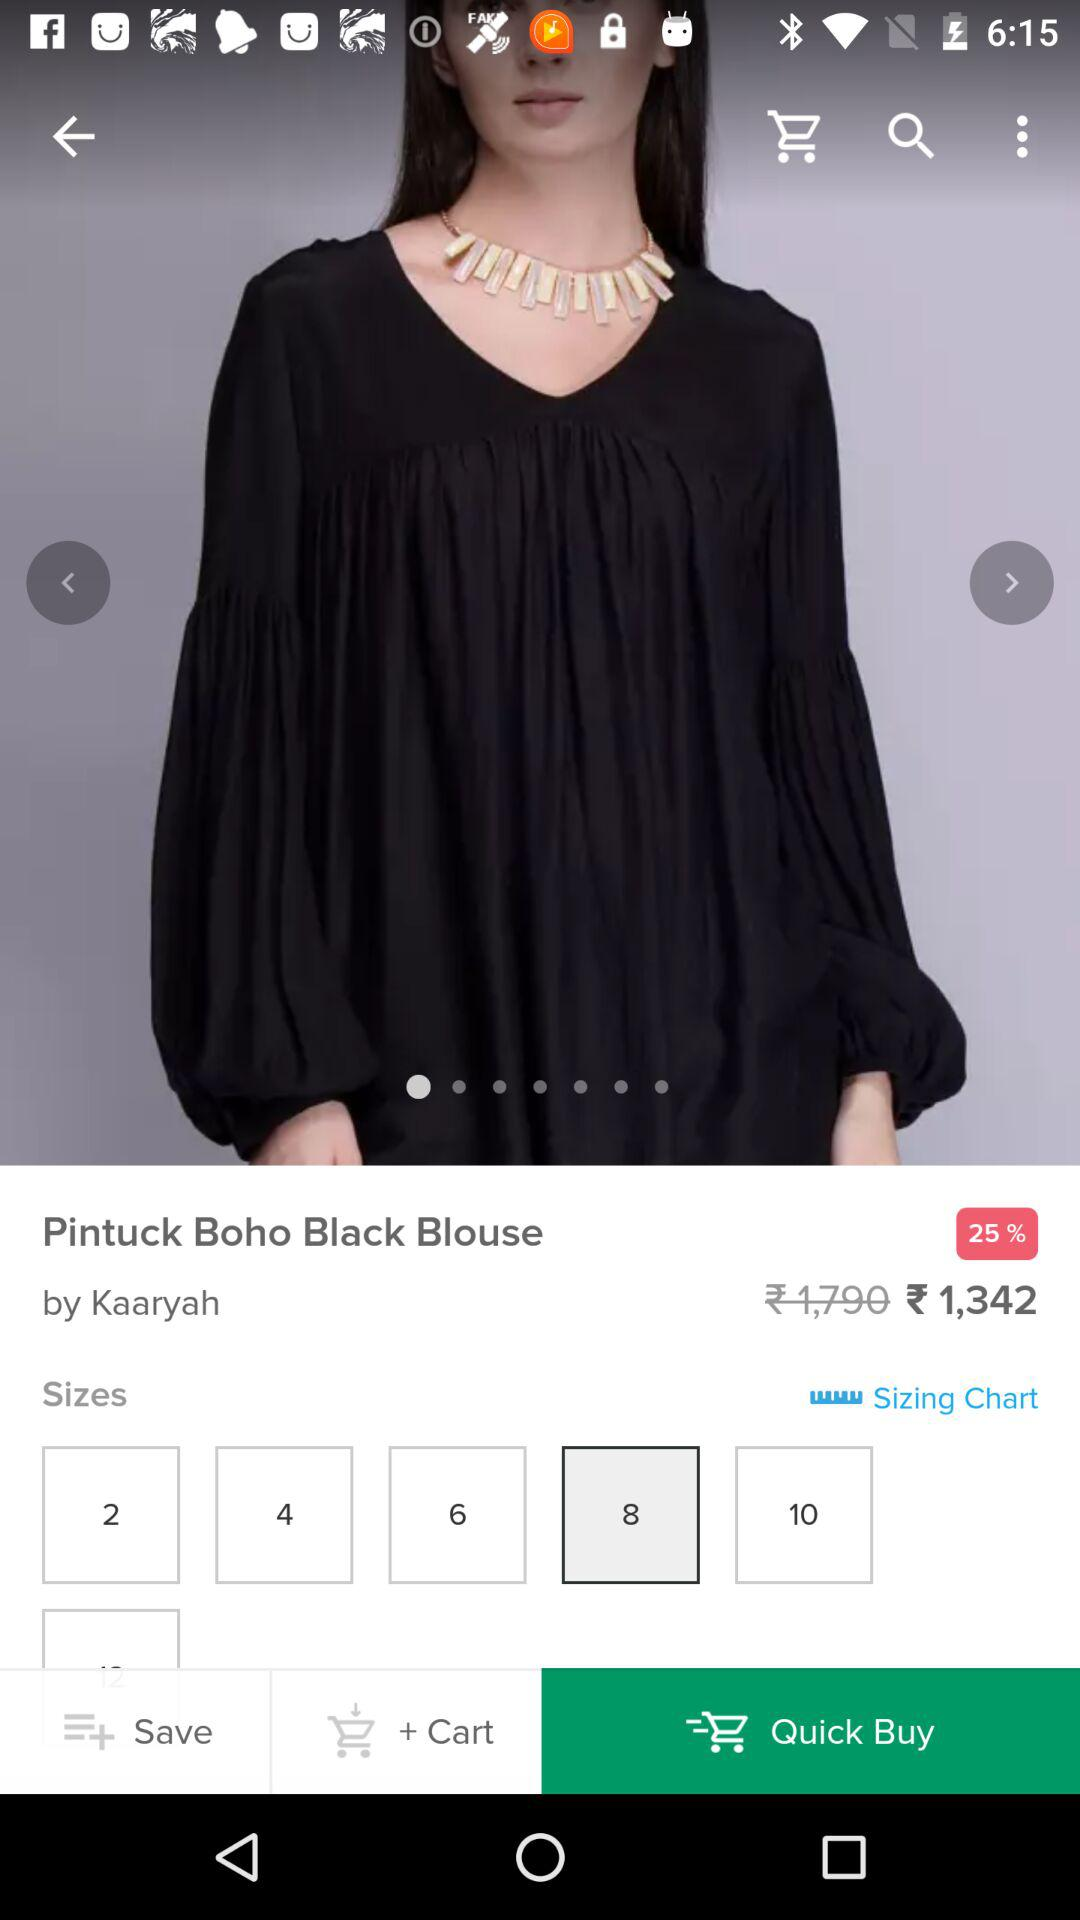What is the percentage discount on the blouse? The discount is 25 percent. 